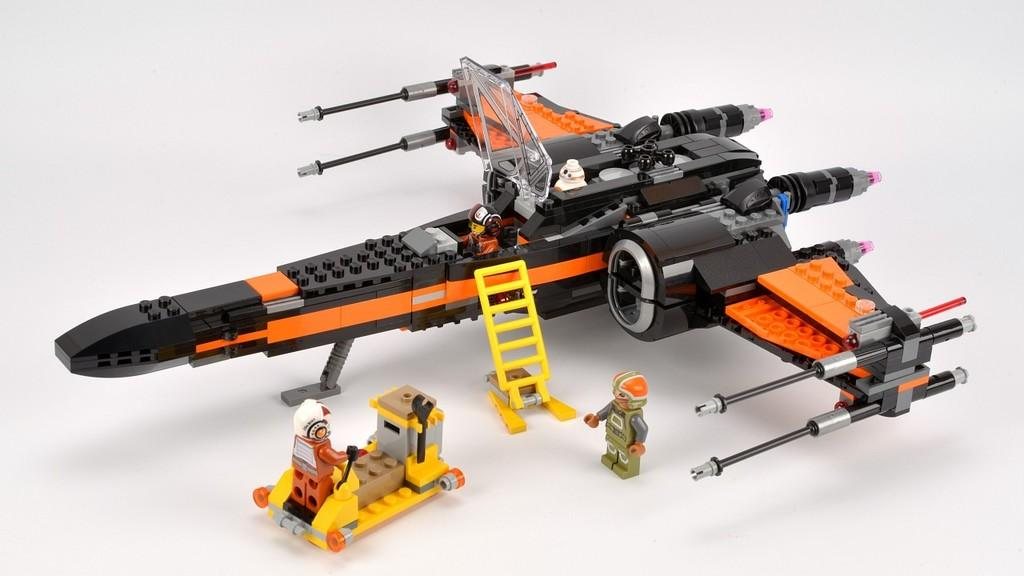What type of objects can be seen in the image? There are toys in the image. What type of joke is being told by the toys in the image? There is no joke being told by the toys in the image, as they are inanimate objects and cannot speak or tell jokes. 